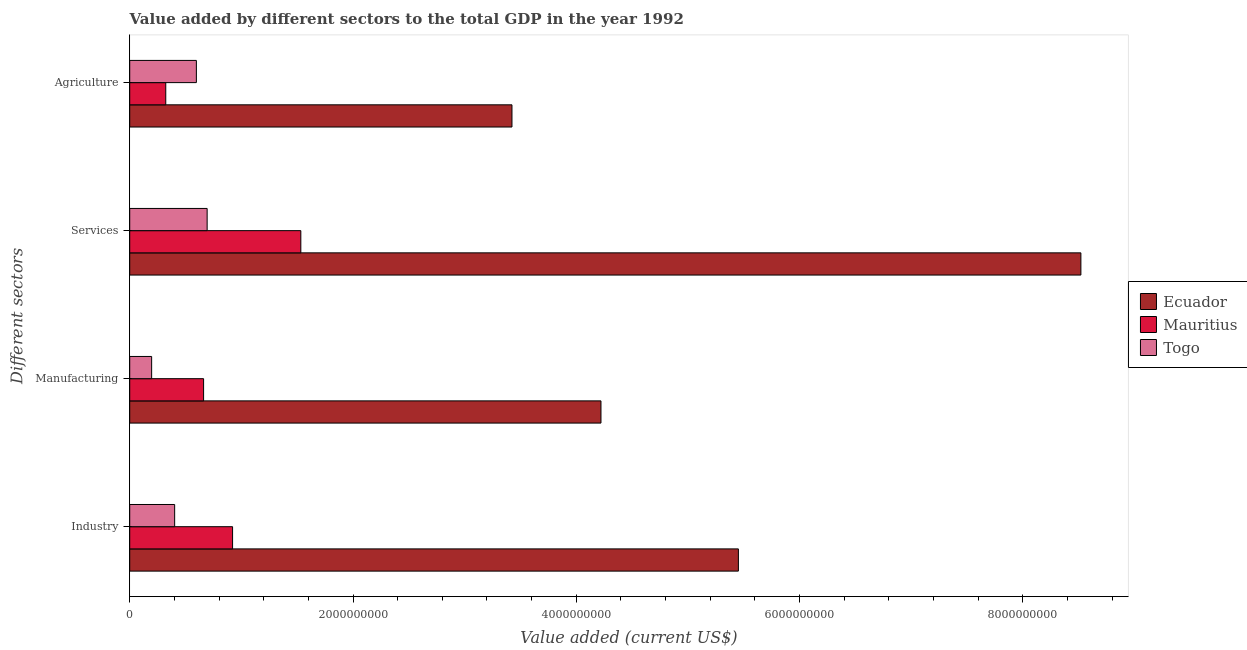How many different coloured bars are there?
Offer a very short reply. 3. How many groups of bars are there?
Make the answer very short. 4. Are the number of bars on each tick of the Y-axis equal?
Ensure brevity in your answer.  Yes. How many bars are there on the 3rd tick from the top?
Provide a short and direct response. 3. What is the label of the 1st group of bars from the top?
Your response must be concise. Agriculture. What is the value added by manufacturing sector in Ecuador?
Your response must be concise. 4.22e+09. Across all countries, what is the maximum value added by manufacturing sector?
Your answer should be very brief. 4.22e+09. Across all countries, what is the minimum value added by services sector?
Give a very brief answer. 6.93e+08. In which country was the value added by manufacturing sector maximum?
Your answer should be very brief. Ecuador. In which country was the value added by industrial sector minimum?
Ensure brevity in your answer.  Togo. What is the total value added by manufacturing sector in the graph?
Your answer should be very brief. 5.08e+09. What is the difference between the value added by industrial sector in Togo and that in Mauritius?
Your answer should be very brief. -5.19e+08. What is the difference between the value added by agricultural sector in Ecuador and the value added by industrial sector in Mauritius?
Your response must be concise. 2.50e+09. What is the average value added by services sector per country?
Ensure brevity in your answer.  3.58e+09. What is the difference between the value added by industrial sector and value added by manufacturing sector in Mauritius?
Offer a very short reply. 2.60e+08. In how many countries, is the value added by services sector greater than 8000000000 US$?
Provide a short and direct response. 1. What is the ratio of the value added by agricultural sector in Ecuador to that in Togo?
Provide a short and direct response. 5.74. What is the difference between the highest and the second highest value added by industrial sector?
Offer a very short reply. 4.53e+09. What is the difference between the highest and the lowest value added by manufacturing sector?
Ensure brevity in your answer.  4.02e+09. Is the sum of the value added by industrial sector in Togo and Ecuador greater than the maximum value added by manufacturing sector across all countries?
Offer a very short reply. Yes. What does the 1st bar from the top in Manufacturing represents?
Provide a succinct answer. Togo. What does the 2nd bar from the bottom in Agriculture represents?
Make the answer very short. Mauritius. How many countries are there in the graph?
Keep it short and to the point. 3. Where does the legend appear in the graph?
Make the answer very short. Center right. What is the title of the graph?
Provide a short and direct response. Value added by different sectors to the total GDP in the year 1992. Does "Sweden" appear as one of the legend labels in the graph?
Your response must be concise. No. What is the label or title of the X-axis?
Give a very brief answer. Value added (current US$). What is the label or title of the Y-axis?
Offer a very short reply. Different sectors. What is the Value added (current US$) of Ecuador in Industry?
Your answer should be compact. 5.45e+09. What is the Value added (current US$) in Mauritius in Industry?
Offer a very short reply. 9.21e+08. What is the Value added (current US$) of Togo in Industry?
Make the answer very short. 4.02e+08. What is the Value added (current US$) of Ecuador in Manufacturing?
Provide a succinct answer. 4.22e+09. What is the Value added (current US$) of Mauritius in Manufacturing?
Provide a succinct answer. 6.62e+08. What is the Value added (current US$) of Togo in Manufacturing?
Your response must be concise. 1.96e+08. What is the Value added (current US$) in Ecuador in Services?
Give a very brief answer. 8.52e+09. What is the Value added (current US$) of Mauritius in Services?
Ensure brevity in your answer.  1.53e+09. What is the Value added (current US$) in Togo in Services?
Offer a very short reply. 6.93e+08. What is the Value added (current US$) in Ecuador in Agriculture?
Make the answer very short. 3.42e+09. What is the Value added (current US$) of Mauritius in Agriculture?
Make the answer very short. 3.23e+08. What is the Value added (current US$) in Togo in Agriculture?
Provide a succinct answer. 5.97e+08. Across all Different sectors, what is the maximum Value added (current US$) of Ecuador?
Make the answer very short. 8.52e+09. Across all Different sectors, what is the maximum Value added (current US$) of Mauritius?
Provide a succinct answer. 1.53e+09. Across all Different sectors, what is the maximum Value added (current US$) of Togo?
Your answer should be very brief. 6.93e+08. Across all Different sectors, what is the minimum Value added (current US$) in Ecuador?
Provide a short and direct response. 3.42e+09. Across all Different sectors, what is the minimum Value added (current US$) in Mauritius?
Your response must be concise. 3.23e+08. Across all Different sectors, what is the minimum Value added (current US$) of Togo?
Your answer should be very brief. 1.96e+08. What is the total Value added (current US$) in Ecuador in the graph?
Ensure brevity in your answer.  2.16e+1. What is the total Value added (current US$) in Mauritius in the graph?
Provide a succinct answer. 3.44e+09. What is the total Value added (current US$) of Togo in the graph?
Provide a short and direct response. 1.89e+09. What is the difference between the Value added (current US$) of Ecuador in Industry and that in Manufacturing?
Your response must be concise. 1.23e+09. What is the difference between the Value added (current US$) of Mauritius in Industry and that in Manufacturing?
Keep it short and to the point. 2.60e+08. What is the difference between the Value added (current US$) of Togo in Industry and that in Manufacturing?
Offer a very short reply. 2.06e+08. What is the difference between the Value added (current US$) of Ecuador in Industry and that in Services?
Give a very brief answer. -3.07e+09. What is the difference between the Value added (current US$) in Mauritius in Industry and that in Services?
Your answer should be very brief. -6.11e+08. What is the difference between the Value added (current US$) in Togo in Industry and that in Services?
Ensure brevity in your answer.  -2.91e+08. What is the difference between the Value added (current US$) of Ecuador in Industry and that in Agriculture?
Your answer should be very brief. 2.03e+09. What is the difference between the Value added (current US$) in Mauritius in Industry and that in Agriculture?
Your answer should be very brief. 5.98e+08. What is the difference between the Value added (current US$) of Togo in Industry and that in Agriculture?
Give a very brief answer. -1.95e+08. What is the difference between the Value added (current US$) in Ecuador in Manufacturing and that in Services?
Your answer should be compact. -4.30e+09. What is the difference between the Value added (current US$) of Mauritius in Manufacturing and that in Services?
Your response must be concise. -8.71e+08. What is the difference between the Value added (current US$) in Togo in Manufacturing and that in Services?
Your answer should be very brief. -4.97e+08. What is the difference between the Value added (current US$) in Ecuador in Manufacturing and that in Agriculture?
Offer a terse response. 7.97e+08. What is the difference between the Value added (current US$) in Mauritius in Manufacturing and that in Agriculture?
Give a very brief answer. 3.39e+08. What is the difference between the Value added (current US$) of Togo in Manufacturing and that in Agriculture?
Offer a terse response. -4.01e+08. What is the difference between the Value added (current US$) in Ecuador in Services and that in Agriculture?
Give a very brief answer. 5.10e+09. What is the difference between the Value added (current US$) in Mauritius in Services and that in Agriculture?
Your answer should be very brief. 1.21e+09. What is the difference between the Value added (current US$) in Togo in Services and that in Agriculture?
Offer a terse response. 9.65e+07. What is the difference between the Value added (current US$) in Ecuador in Industry and the Value added (current US$) in Mauritius in Manufacturing?
Your answer should be compact. 4.79e+09. What is the difference between the Value added (current US$) in Ecuador in Industry and the Value added (current US$) in Togo in Manufacturing?
Your response must be concise. 5.26e+09. What is the difference between the Value added (current US$) of Mauritius in Industry and the Value added (current US$) of Togo in Manufacturing?
Give a very brief answer. 7.25e+08. What is the difference between the Value added (current US$) in Ecuador in Industry and the Value added (current US$) in Mauritius in Services?
Ensure brevity in your answer.  3.92e+09. What is the difference between the Value added (current US$) of Ecuador in Industry and the Value added (current US$) of Togo in Services?
Ensure brevity in your answer.  4.76e+09. What is the difference between the Value added (current US$) in Mauritius in Industry and the Value added (current US$) in Togo in Services?
Give a very brief answer. 2.28e+08. What is the difference between the Value added (current US$) of Ecuador in Industry and the Value added (current US$) of Mauritius in Agriculture?
Offer a very short reply. 5.13e+09. What is the difference between the Value added (current US$) of Ecuador in Industry and the Value added (current US$) of Togo in Agriculture?
Make the answer very short. 4.85e+09. What is the difference between the Value added (current US$) in Mauritius in Industry and the Value added (current US$) in Togo in Agriculture?
Offer a very short reply. 3.24e+08. What is the difference between the Value added (current US$) of Ecuador in Manufacturing and the Value added (current US$) of Mauritius in Services?
Make the answer very short. 2.69e+09. What is the difference between the Value added (current US$) in Ecuador in Manufacturing and the Value added (current US$) in Togo in Services?
Make the answer very short. 3.53e+09. What is the difference between the Value added (current US$) of Mauritius in Manufacturing and the Value added (current US$) of Togo in Services?
Provide a short and direct response. -3.18e+07. What is the difference between the Value added (current US$) of Ecuador in Manufacturing and the Value added (current US$) of Mauritius in Agriculture?
Provide a short and direct response. 3.90e+09. What is the difference between the Value added (current US$) in Ecuador in Manufacturing and the Value added (current US$) in Togo in Agriculture?
Your response must be concise. 3.62e+09. What is the difference between the Value added (current US$) in Mauritius in Manufacturing and the Value added (current US$) in Togo in Agriculture?
Offer a very short reply. 6.47e+07. What is the difference between the Value added (current US$) in Ecuador in Services and the Value added (current US$) in Mauritius in Agriculture?
Make the answer very short. 8.20e+09. What is the difference between the Value added (current US$) in Ecuador in Services and the Value added (current US$) in Togo in Agriculture?
Your answer should be very brief. 7.92e+09. What is the difference between the Value added (current US$) of Mauritius in Services and the Value added (current US$) of Togo in Agriculture?
Provide a short and direct response. 9.36e+08. What is the average Value added (current US$) in Ecuador per Different sectors?
Offer a terse response. 5.40e+09. What is the average Value added (current US$) in Mauritius per Different sectors?
Your answer should be very brief. 8.60e+08. What is the average Value added (current US$) of Togo per Different sectors?
Your response must be concise. 4.72e+08. What is the difference between the Value added (current US$) of Ecuador and Value added (current US$) of Mauritius in Industry?
Make the answer very short. 4.53e+09. What is the difference between the Value added (current US$) of Ecuador and Value added (current US$) of Togo in Industry?
Offer a terse response. 5.05e+09. What is the difference between the Value added (current US$) in Mauritius and Value added (current US$) in Togo in Industry?
Provide a short and direct response. 5.19e+08. What is the difference between the Value added (current US$) of Ecuador and Value added (current US$) of Mauritius in Manufacturing?
Give a very brief answer. 3.56e+09. What is the difference between the Value added (current US$) in Ecuador and Value added (current US$) in Togo in Manufacturing?
Your answer should be very brief. 4.02e+09. What is the difference between the Value added (current US$) in Mauritius and Value added (current US$) in Togo in Manufacturing?
Give a very brief answer. 4.65e+08. What is the difference between the Value added (current US$) in Ecuador and Value added (current US$) in Mauritius in Services?
Provide a short and direct response. 6.99e+09. What is the difference between the Value added (current US$) of Ecuador and Value added (current US$) of Togo in Services?
Your answer should be very brief. 7.83e+09. What is the difference between the Value added (current US$) of Mauritius and Value added (current US$) of Togo in Services?
Your answer should be compact. 8.39e+08. What is the difference between the Value added (current US$) of Ecuador and Value added (current US$) of Mauritius in Agriculture?
Offer a terse response. 3.10e+09. What is the difference between the Value added (current US$) of Ecuador and Value added (current US$) of Togo in Agriculture?
Provide a succinct answer. 2.83e+09. What is the difference between the Value added (current US$) of Mauritius and Value added (current US$) of Togo in Agriculture?
Your answer should be compact. -2.74e+08. What is the ratio of the Value added (current US$) in Ecuador in Industry to that in Manufacturing?
Ensure brevity in your answer.  1.29. What is the ratio of the Value added (current US$) in Mauritius in Industry to that in Manufacturing?
Ensure brevity in your answer.  1.39. What is the ratio of the Value added (current US$) in Togo in Industry to that in Manufacturing?
Offer a very short reply. 2.05. What is the ratio of the Value added (current US$) in Ecuador in Industry to that in Services?
Your answer should be very brief. 0.64. What is the ratio of the Value added (current US$) of Mauritius in Industry to that in Services?
Make the answer very short. 0.6. What is the ratio of the Value added (current US$) in Togo in Industry to that in Services?
Keep it short and to the point. 0.58. What is the ratio of the Value added (current US$) in Ecuador in Industry to that in Agriculture?
Offer a terse response. 1.59. What is the ratio of the Value added (current US$) of Mauritius in Industry to that in Agriculture?
Your answer should be very brief. 2.85. What is the ratio of the Value added (current US$) of Togo in Industry to that in Agriculture?
Keep it short and to the point. 0.67. What is the ratio of the Value added (current US$) of Ecuador in Manufacturing to that in Services?
Offer a very short reply. 0.5. What is the ratio of the Value added (current US$) of Mauritius in Manufacturing to that in Services?
Your answer should be compact. 0.43. What is the ratio of the Value added (current US$) in Togo in Manufacturing to that in Services?
Keep it short and to the point. 0.28. What is the ratio of the Value added (current US$) of Ecuador in Manufacturing to that in Agriculture?
Provide a short and direct response. 1.23. What is the ratio of the Value added (current US$) of Mauritius in Manufacturing to that in Agriculture?
Offer a terse response. 2.05. What is the ratio of the Value added (current US$) in Togo in Manufacturing to that in Agriculture?
Offer a terse response. 0.33. What is the ratio of the Value added (current US$) in Ecuador in Services to that in Agriculture?
Provide a short and direct response. 2.49. What is the ratio of the Value added (current US$) in Mauritius in Services to that in Agriculture?
Keep it short and to the point. 4.75. What is the ratio of the Value added (current US$) of Togo in Services to that in Agriculture?
Your answer should be compact. 1.16. What is the difference between the highest and the second highest Value added (current US$) of Ecuador?
Provide a short and direct response. 3.07e+09. What is the difference between the highest and the second highest Value added (current US$) of Mauritius?
Your answer should be compact. 6.11e+08. What is the difference between the highest and the second highest Value added (current US$) of Togo?
Provide a short and direct response. 9.65e+07. What is the difference between the highest and the lowest Value added (current US$) in Ecuador?
Give a very brief answer. 5.10e+09. What is the difference between the highest and the lowest Value added (current US$) in Mauritius?
Give a very brief answer. 1.21e+09. What is the difference between the highest and the lowest Value added (current US$) of Togo?
Provide a short and direct response. 4.97e+08. 